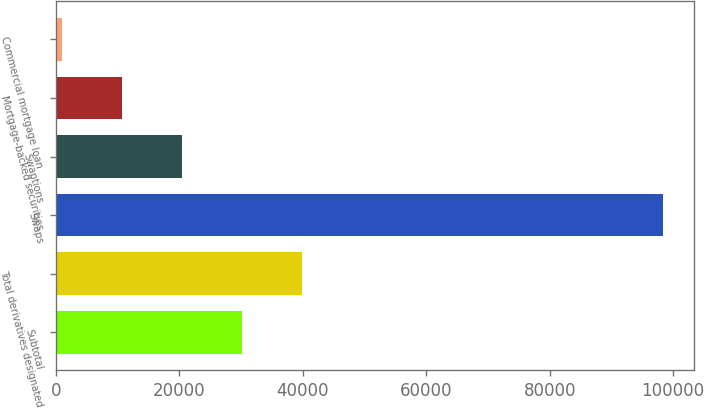Convert chart. <chart><loc_0><loc_0><loc_500><loc_500><bar_chart><fcel>Subtotal<fcel>Total derivatives designated<fcel>Swaps<fcel>Swaptions<fcel>Mortgage-backed securities<fcel>Commercial mortgage loan<nl><fcel>30218.3<fcel>39959.4<fcel>98406<fcel>20477.2<fcel>10736.1<fcel>995<nl></chart> 